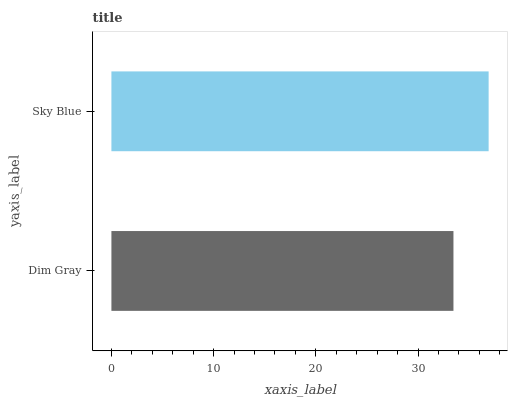Is Dim Gray the minimum?
Answer yes or no. Yes. Is Sky Blue the maximum?
Answer yes or no. Yes. Is Sky Blue the minimum?
Answer yes or no. No. Is Sky Blue greater than Dim Gray?
Answer yes or no. Yes. Is Dim Gray less than Sky Blue?
Answer yes or no. Yes. Is Dim Gray greater than Sky Blue?
Answer yes or no. No. Is Sky Blue less than Dim Gray?
Answer yes or no. No. Is Sky Blue the high median?
Answer yes or no. Yes. Is Dim Gray the low median?
Answer yes or no. Yes. Is Dim Gray the high median?
Answer yes or no. No. Is Sky Blue the low median?
Answer yes or no. No. 